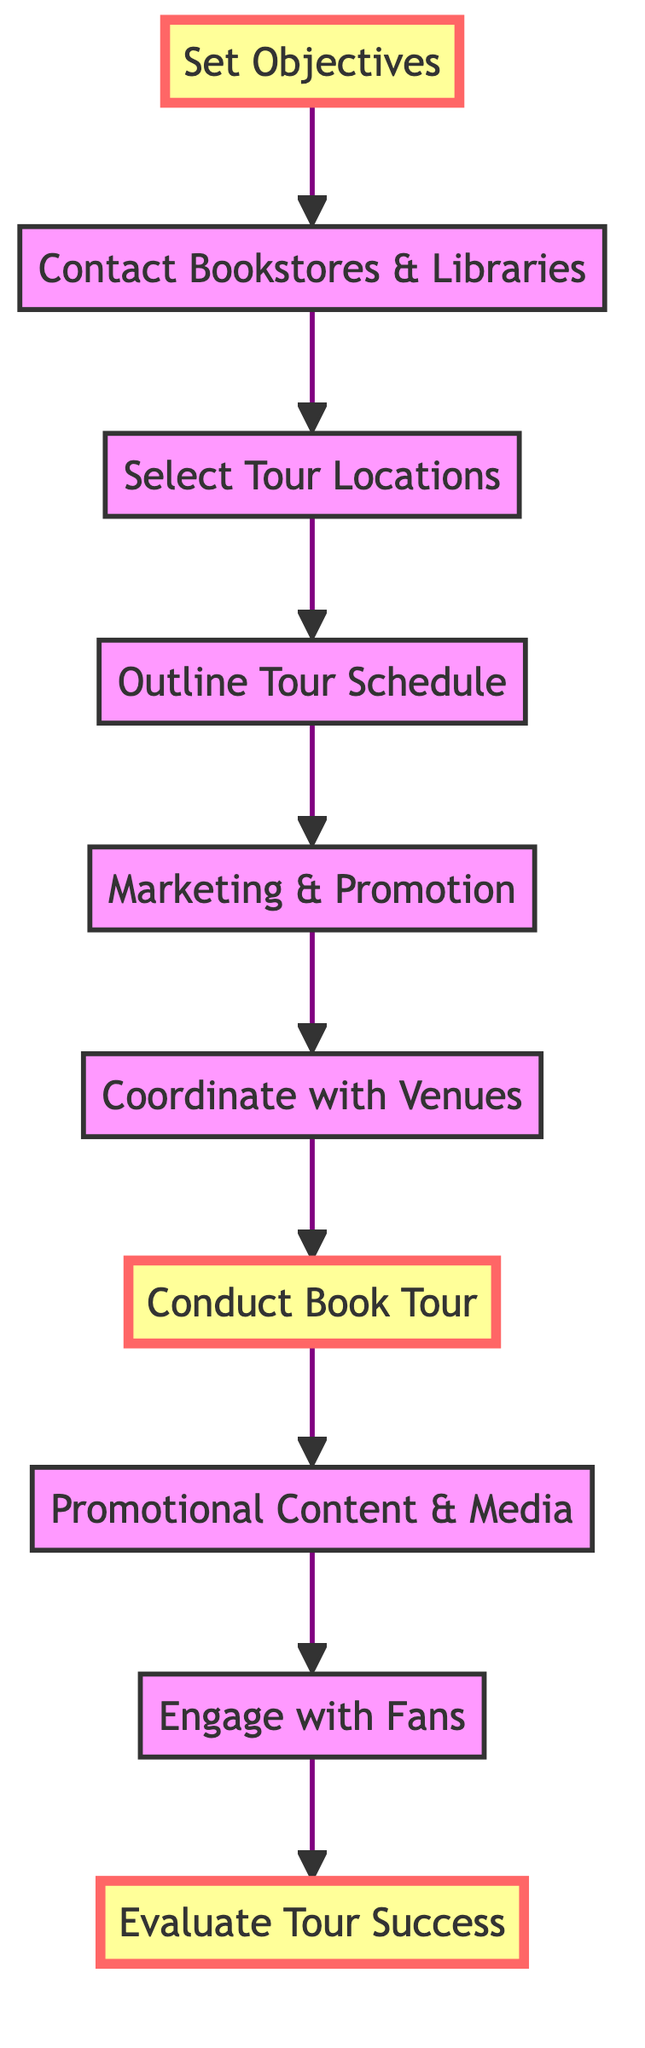What is the final step in the diagram? The diagram flows from the bottom to the top, and the last node in that flow is "Evaluate Tour Success" which is the final step to be taken after the book tour is completed.
Answer: Evaluate Tour Success How many steps are there in total displayed in the diagram? By counting the individual steps listed in the flowchart, we see there are a total of ten steps from "Set Objectives" to "Evaluate Tour Success".
Answer: 10 What is the step directly before conducting the book tour? Looking at the flowchart, just before "Conduct Book Tour" is "Coordinate with Venues", which indicates the required planning step necessary before the actual tour occurs.
Answer: Coordinate with Venues Which step focuses on defining goals? The step that focuses on setting clear goals is "Set Objectives", which is the starting point of the entire process as indicated in the flowchart.
Answer: Set Objectives What is the relationship between "Engage with Fans" and "Promotional Content & Media"? In the diagram, "Engage with Fans" comes directly after "Promotional Content & Media", meaning after promotional activities, interacting with fans becomes the next logical step.
Answer: Engage with Fans If a writer conducts a tour but does not engage with fans, which step is missing? The flowchart indicates that if "Conduct Book Tour" happens but "Engage with Fans" does not follow, then the tour experiences a lack of connection with the audience which is essential for fan growth.
Answer: Engage with Fans What step follows after outlining the tour schedule? According to the flowchart, after the step "Outline Tour Schedule", the next step is "Marketing & Promotion", which highlights the need to market events post-scheduling.
Answer: Marketing & Promotion What key action is taken after visiting bookstores and libraries? Following "Contact Bookstores & Libraries", the next step is "Select Tour Locations", which shows that confirming venues comes after contacting to ensure good locations for the tour.
Answer: Select Tour Locations What is the main purpose of conducting a book tour as highlighted in the flowchart? The primary purpose illustrated through the steps leading up to "Conduct Book Tour" indicates it's to promote the book while engaging a live audience effectively.
Answer: To promote the book 